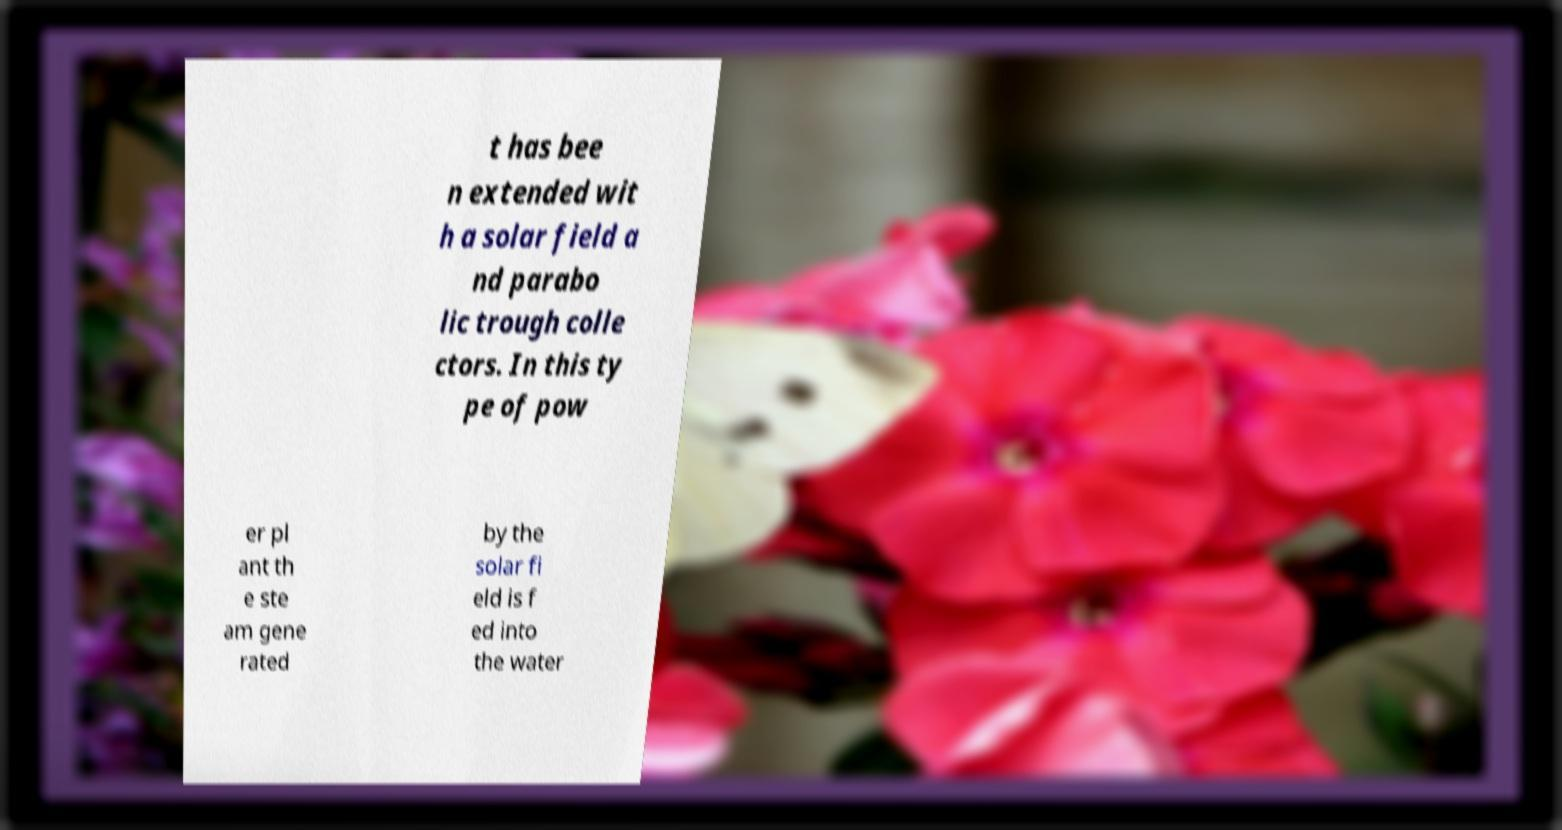There's text embedded in this image that I need extracted. Can you transcribe it verbatim? t has bee n extended wit h a solar field a nd parabo lic trough colle ctors. In this ty pe of pow er pl ant th e ste am gene rated by the solar fi eld is f ed into the water 